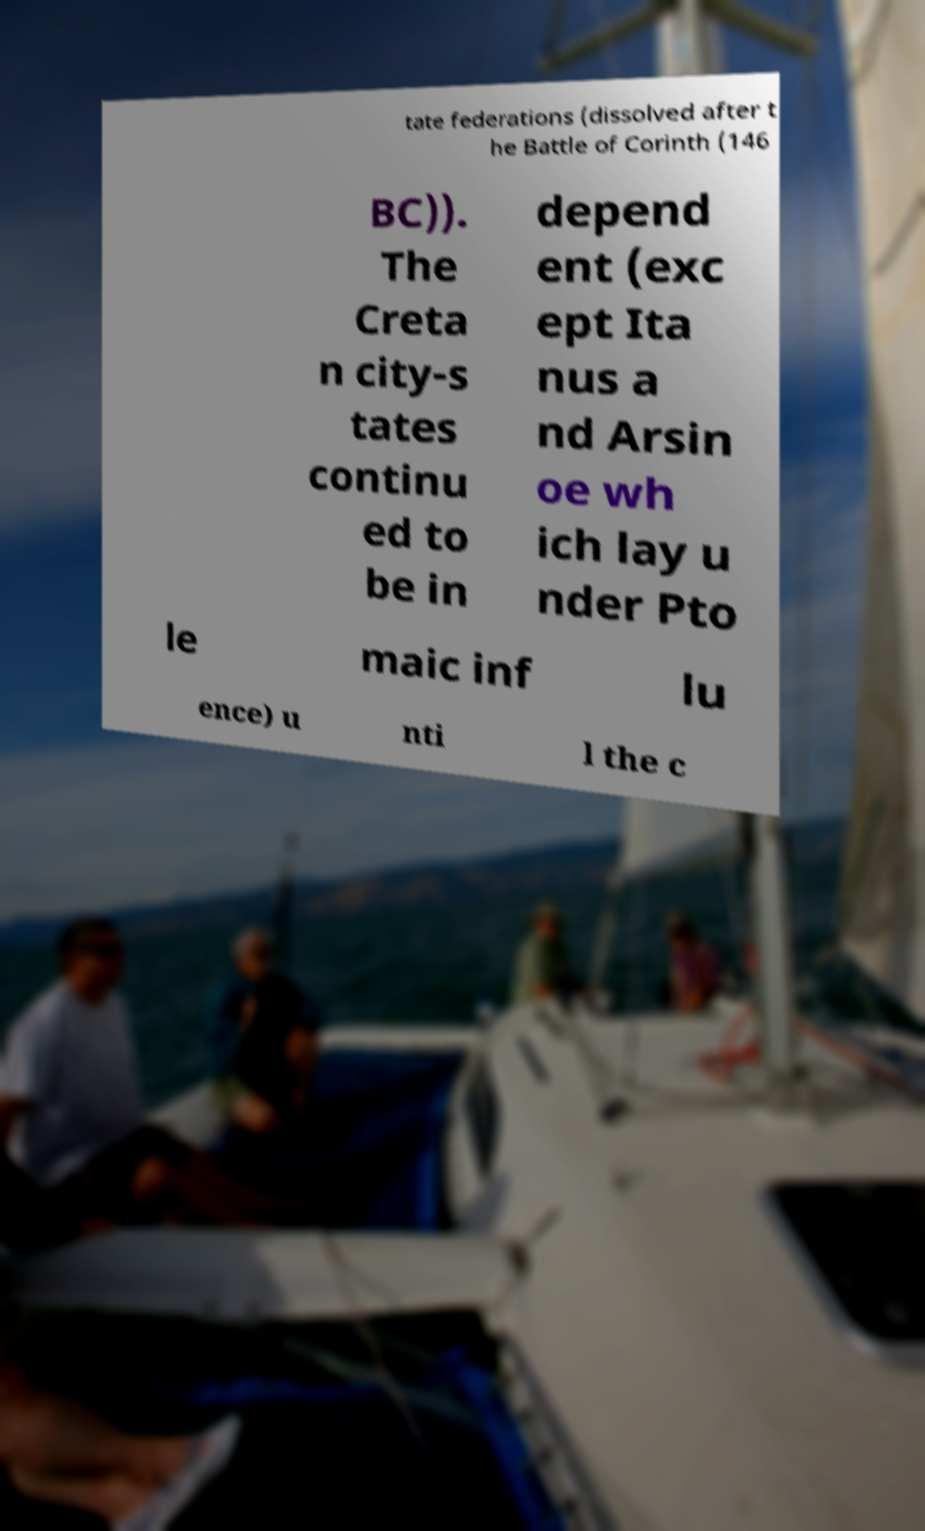Please read and relay the text visible in this image. What does it say? tate federations (dissolved after t he Battle of Corinth (146 BC)). The Creta n city-s tates continu ed to be in depend ent (exc ept Ita nus a nd Arsin oe wh ich lay u nder Pto le maic inf lu ence) u nti l the c 